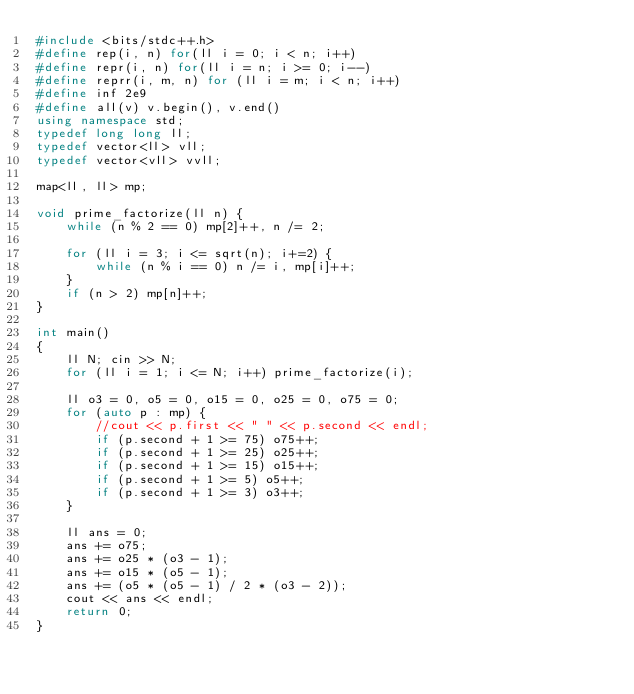<code> <loc_0><loc_0><loc_500><loc_500><_C++_>#include <bits/stdc++.h>
#define rep(i, n) for(ll i = 0; i < n; i++)
#define repr(i, n) for(ll i = n; i >= 0; i--)
#define reprr(i, m, n) for (ll i = m; i < n; i++)
#define inf 2e9
#define all(v) v.begin(), v.end()
using namespace std;
typedef long long ll;
typedef vector<ll> vll;
typedef vector<vll> vvll;

map<ll, ll> mp;

void prime_factorize(ll n) {
    while (n % 2 == 0) mp[2]++, n /= 2;

    for (ll i = 3; i <= sqrt(n); i+=2) {
        while (n % i == 0) n /= i, mp[i]++;
    }
    if (n > 2) mp[n]++;
}

int main()
{
    ll N; cin >> N;
    for (ll i = 1; i <= N; i++) prime_factorize(i);

    ll o3 = 0, o5 = 0, o15 = 0, o25 = 0, o75 = 0;
    for (auto p : mp) {
        //cout << p.first << " " << p.second << endl;
        if (p.second + 1 >= 75) o75++;
        if (p.second + 1 >= 25) o25++;
        if (p.second + 1 >= 15) o15++;
        if (p.second + 1 >= 5) o5++;
        if (p.second + 1 >= 3) o3++; 
    }

    ll ans = 0;
    ans += o75;
    ans += o25 * (o3 - 1);
    ans += o15 * (o5 - 1);
    ans += (o5 * (o5 - 1) / 2 * (o3 - 2));
    cout << ans << endl;
    return 0;
}</code> 